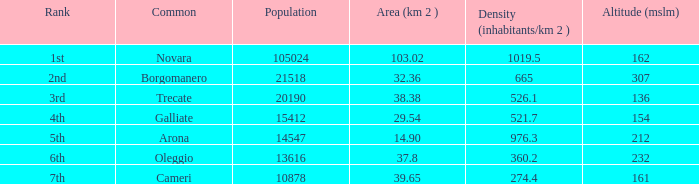02? Novara. 